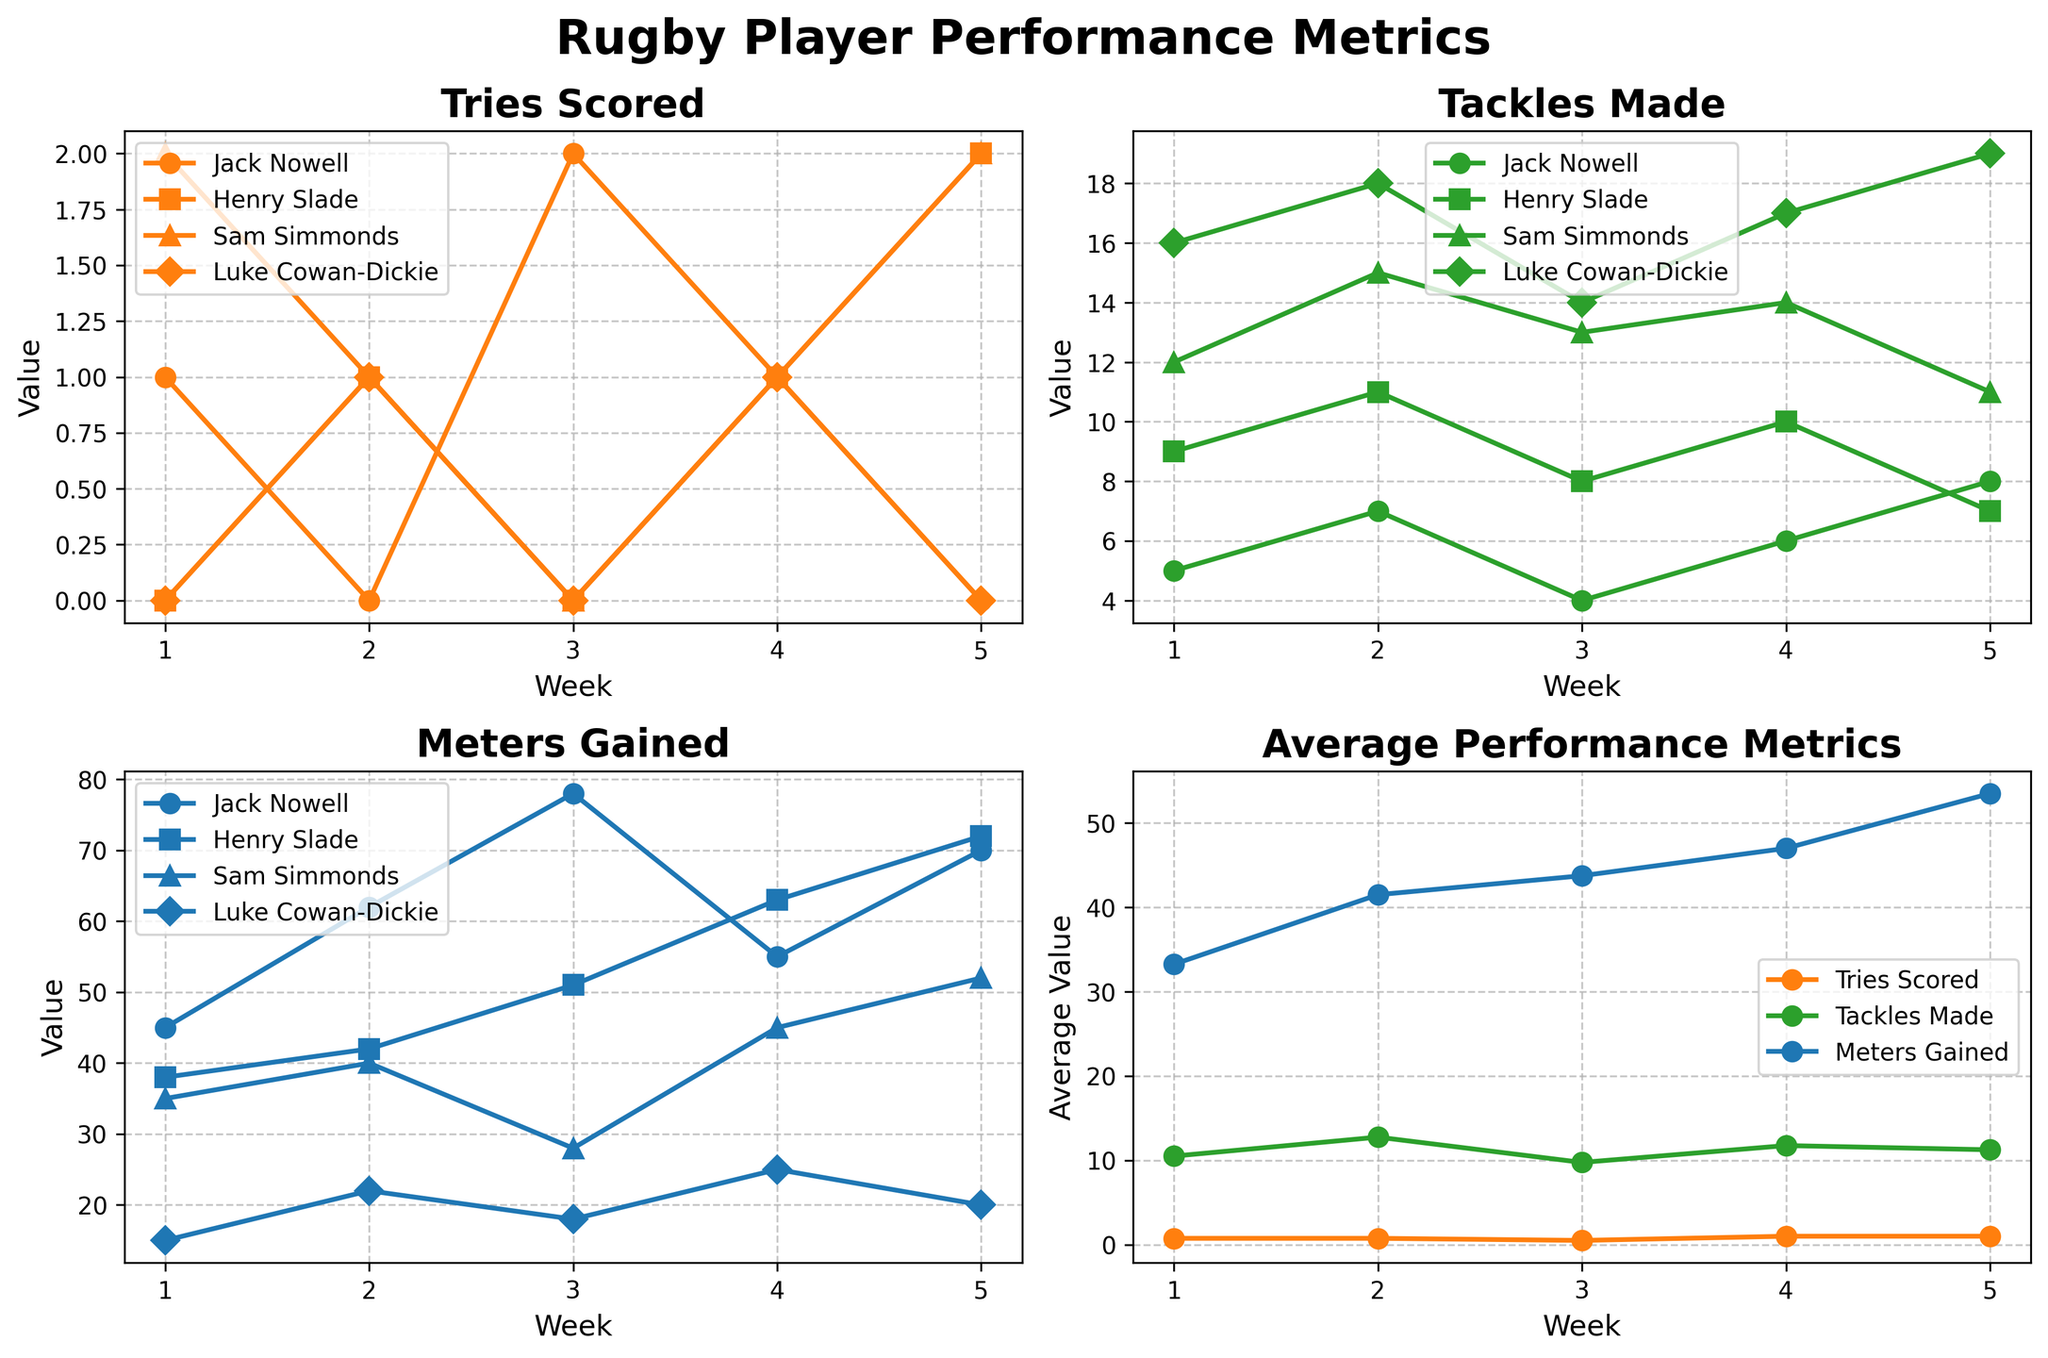What is the trend of Tries Scored by Sam Simmonds over the weeks? To determine the trend, track the position of Sam Simmonds' data points in the "Tries Scored" subplot. Sam started with 2 tries in Week 1, dipped to 1 in Week 2, dropped to 0 in Week 3, returned to 1 in Week 4, and finally increased to 2 in Week 5.
Answer: Increasing trend with fluctuations Which player has made the most tackles in Week 3? By looking at the "Tackles Made" subplot for Week 3, identify the player with the highest data point. Sam Simmonds made 13 tackles, which is the highest among the players.
Answer: Sam Simmonds How does the average value of meters gained in Week 5 compare to Week 1? Locate the "Average Performance Metrics" subplot, and compare the average "Meters Gained" for Week 5 and Week 1. The average meters gained has increased from Week 1 to Week 5.
Answer: Increased Which player scored the maximum number of tries in any week? Observe individual "Tries Scored" subplot to find the highest peak for any player across all weeks. Sam Simmonds scored 2 tries in both Week 1 and Week 5, which is the maximum.
Answer: Sam Simmonds How have Henry Slade's tackles made changed from Week 1 to Week 5? Trace Henry Slade's data points in the "Tackles Made" subplot from Week 1 to Week 5. He starts at 9 tackles in Week 1 and decreases slightly to 7 tackles by Week 5, passing through higher values in between.
Answer: Decreased Whose performance in meters gained saw the most variability? Check the "Meters Gained" subplot, and observe the fluctuation in each player's data points. Jack Nowell’s meters gained fluctuate sharply across weeks, indicating high variability.
Answer: Jack Nowell Compare the total tries scored by Henry Slade and Luke Cowan-Dickie over the five weeks. Sum up the tries scored by both players: Henry Slade scored a total of 4 tries (0+1+0+1+2), and Luke Cowan-Dickie scored 2 tries (0+1+0+1+0). Comparatively, Henry Slade scored more tries.
Answer: Henry Slade What is the pattern of Jack Nowell's meters gained over the season? In the "Meters Gained" subplot, follow the data points for Jack Nowell across all weeks. He starts with 45 meters in Week 1, peaks at 78 meters in Week 3, and fluctuates, ending with 70 meters in Week 5.
Answer: Fluctuating Who had the highest number of tackles made in any given week? In the "Tackles Made" subplot, identify the highest single data point. Luke Cowan-Dickie made 19 tackles in Week 5, which is the highest in any week.
Answer: Luke Cowan-Dickie 